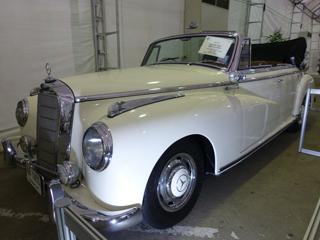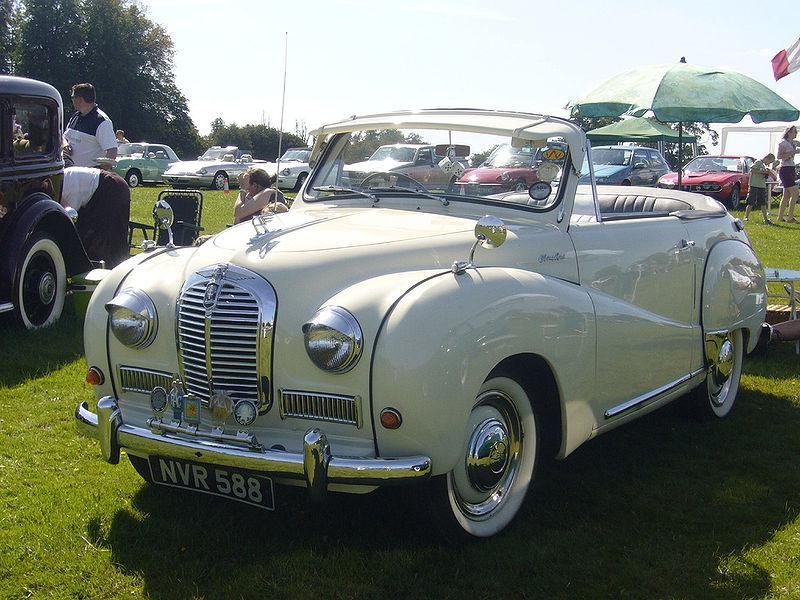The first image is the image on the left, the second image is the image on the right. Given the left and right images, does the statement "Both images show shiny painted exteriors of antique convertibles in good condition." hold true? Answer yes or no. Yes. The first image is the image on the left, the second image is the image on the right. Assess this claim about the two images: "There are multiple cars behind a parked classic car in one of the images.". Correct or not? Answer yes or no. Yes. 